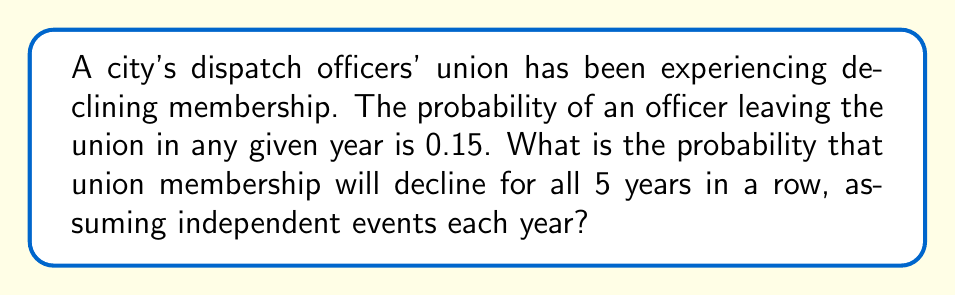Help me with this question. To solve this problem, we need to follow these steps:

1) The probability of union membership declining in a single year is 0.15.

2) We want to find the probability of this happening for 5 consecutive years.

3) Since we assume these are independent events, we can use the multiplication rule of probability.

4) The probability of independent events all occurring is the product of their individual probabilities.

5) Therefore, we need to calculate $0.15^5$.

6) Using a calculator or computing by hand:

   $$0.15^5 = 0.15 \times 0.15 \times 0.15 \times 0.15 \times 0.15 = 0.0000759375$$

7) This can be expressed as approximately 0.000076 or 7.6 × 10⁻⁵.

This result suggests that the probability of union membership declining for 5 consecutive years is very low, which could be used to argue against concerns about long-term union decline.
Answer: $0.15^5 \approx 0.000076$ 